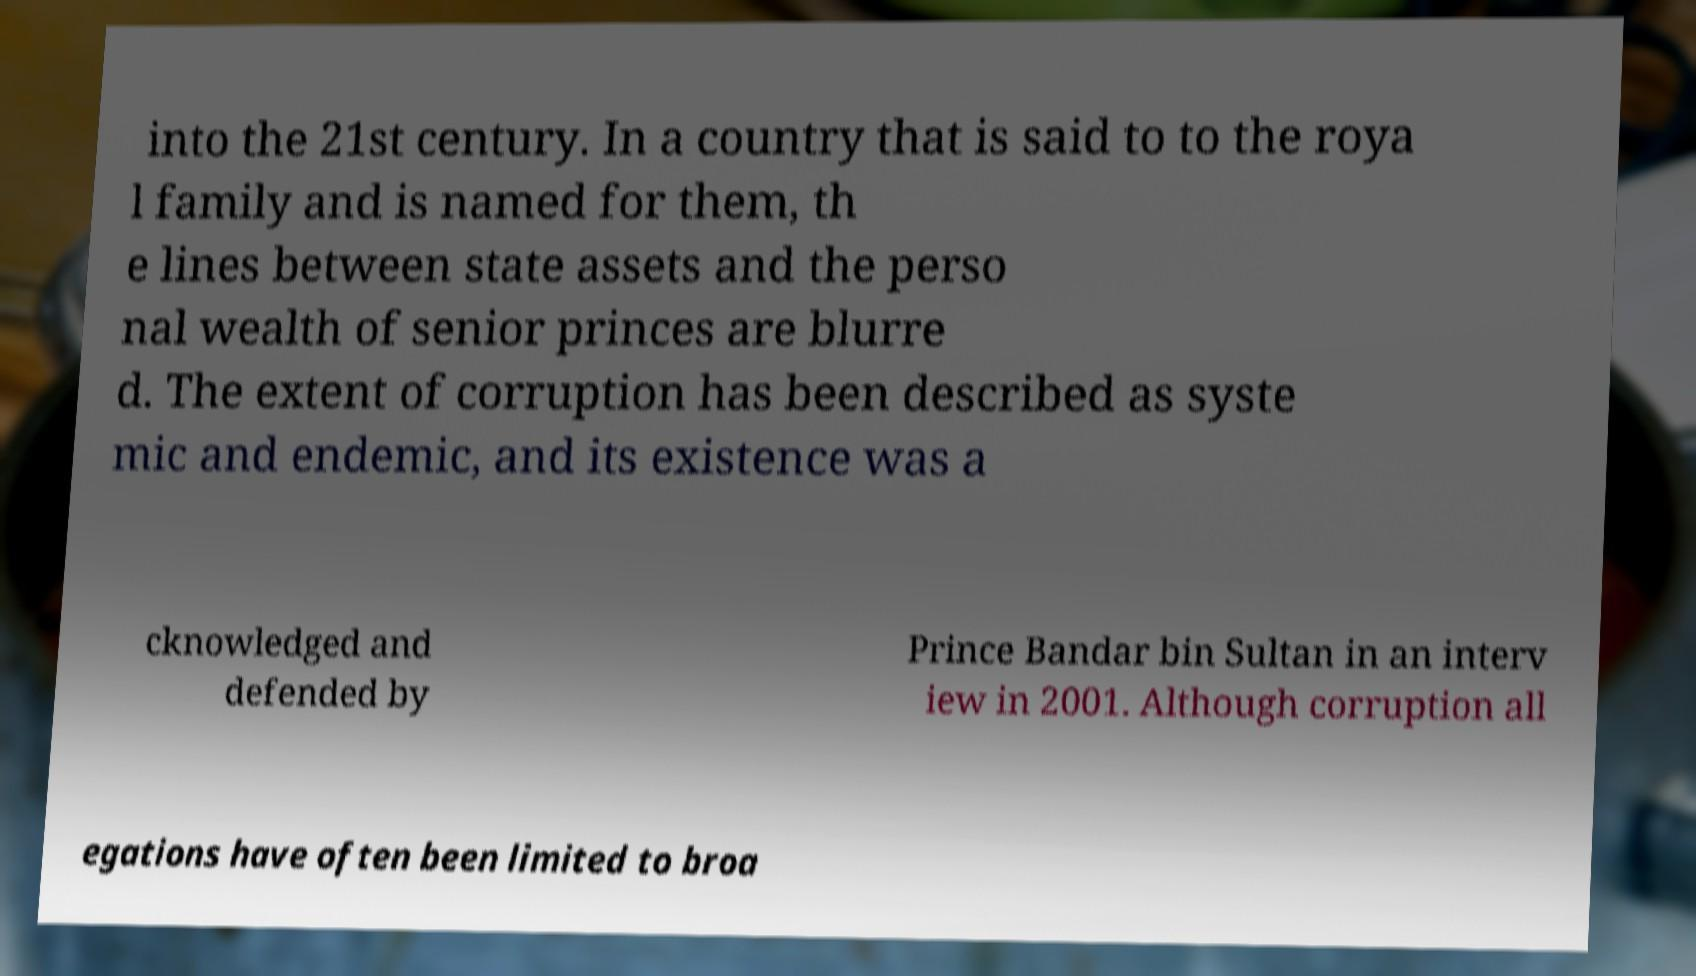What messages or text are displayed in this image? I need them in a readable, typed format. into the 21st century. In a country that is said to to the roya l family and is named for them, th e lines between state assets and the perso nal wealth of senior princes are blurre d. The extent of corruption has been described as syste mic and endemic, and its existence was a cknowledged and defended by Prince Bandar bin Sultan in an interv iew in 2001. Although corruption all egations have often been limited to broa 